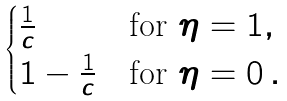Convert formula to latex. <formula><loc_0><loc_0><loc_500><loc_500>\begin{cases} \frac { 1 } { c } & \text {for $\eta=1$} , \\ 1 - \frac { 1 } { c } & \text {for $\eta=0$} \, . \end{cases}</formula> 